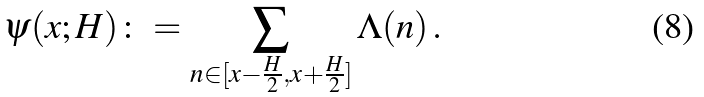Convert formula to latex. <formula><loc_0><loc_0><loc_500><loc_500>\psi ( x ; H ) \colon = \sum _ { n \in [ x - \frac { H } { 2 } , x + \frac { H } { 2 } ] } \Lambda ( n ) \, .</formula> 